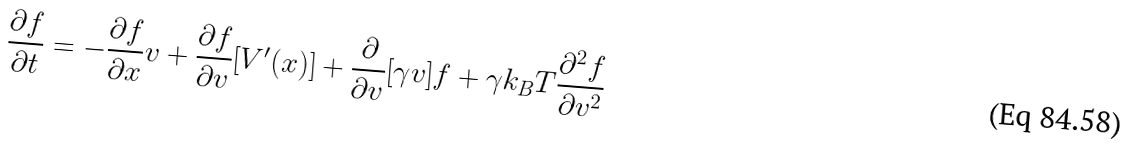Convert formula to latex. <formula><loc_0><loc_0><loc_500><loc_500>\frac { \partial f } { \partial t } = - \frac { \partial f } { \partial x } v + \frac { \partial f } { \partial v } [ V ^ { \prime } ( x ) ] + \frac { \partial } { \partial v } [ \gamma v ] f + \gamma k _ { B } T \frac { \partial ^ { 2 } f } { \partial v ^ { 2 } }</formula> 